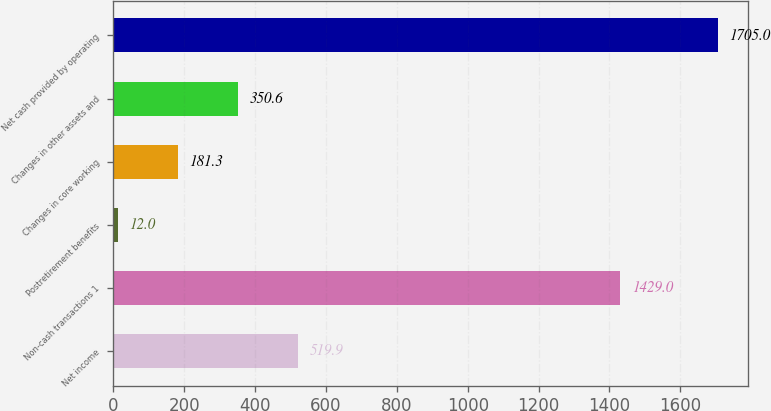Convert chart to OTSL. <chart><loc_0><loc_0><loc_500><loc_500><bar_chart><fcel>Net income<fcel>Non-cash transactions 1<fcel>Postretirement benefits<fcel>Changes in core working<fcel>Changes in other assets and<fcel>Net cash provided by operating<nl><fcel>519.9<fcel>1429<fcel>12<fcel>181.3<fcel>350.6<fcel>1705<nl></chart> 